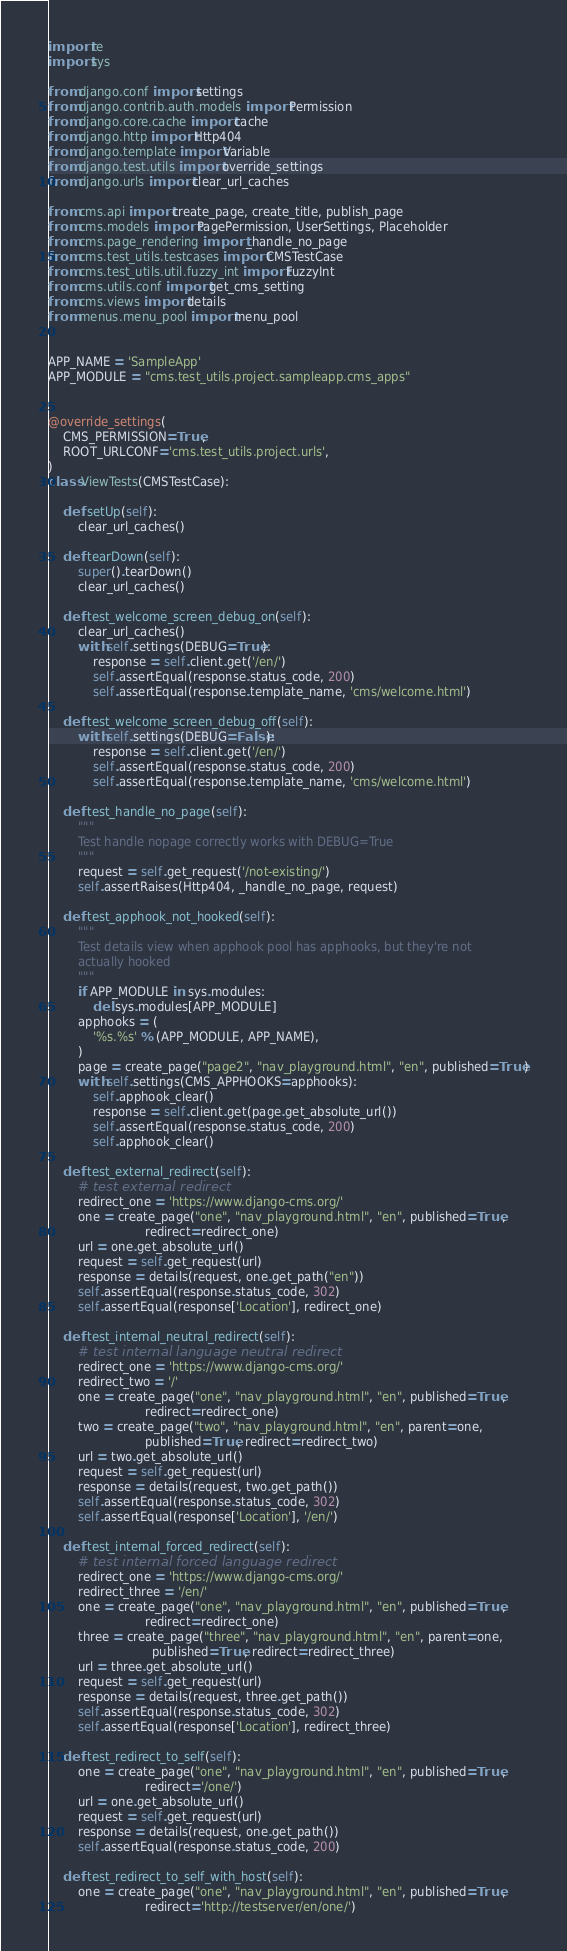Convert code to text. <code><loc_0><loc_0><loc_500><loc_500><_Python_>import re
import sys

from django.conf import settings
from django.contrib.auth.models import Permission
from django.core.cache import cache
from django.http import Http404
from django.template import Variable
from django.test.utils import override_settings
from django.urls import clear_url_caches

from cms.api import create_page, create_title, publish_page
from cms.models import PagePermission, UserSettings, Placeholder
from cms.page_rendering import _handle_no_page
from cms.test_utils.testcases import CMSTestCase
from cms.test_utils.util.fuzzy_int import FuzzyInt
from cms.utils.conf import get_cms_setting
from cms.views import details
from menus.menu_pool import menu_pool


APP_NAME = 'SampleApp'
APP_MODULE = "cms.test_utils.project.sampleapp.cms_apps"


@override_settings(
    CMS_PERMISSION=True,
    ROOT_URLCONF='cms.test_utils.project.urls',
)
class ViewTests(CMSTestCase):

    def setUp(self):
        clear_url_caches()

    def tearDown(self):
        super().tearDown()
        clear_url_caches()

    def test_welcome_screen_debug_on(self):
        clear_url_caches()
        with self.settings(DEBUG=True):
            response = self.client.get('/en/')
            self.assertEqual(response.status_code, 200)
            self.assertEqual(response.template_name, 'cms/welcome.html')

    def test_welcome_screen_debug_off(self):
        with self.settings(DEBUG=False):
            response = self.client.get('/en/')
            self.assertEqual(response.status_code, 200)
            self.assertEqual(response.template_name, 'cms/welcome.html')

    def test_handle_no_page(self):
        """
        Test handle nopage correctly works with DEBUG=True
        """
        request = self.get_request('/not-existing/')
        self.assertRaises(Http404, _handle_no_page, request)

    def test_apphook_not_hooked(self):
        """
        Test details view when apphook pool has apphooks, but they're not
        actually hooked
        """
        if APP_MODULE in sys.modules:
            del sys.modules[APP_MODULE]
        apphooks = (
            '%s.%s' % (APP_MODULE, APP_NAME),
        )
        page = create_page("page2", "nav_playground.html", "en", published=True)
        with self.settings(CMS_APPHOOKS=apphooks):
            self.apphook_clear()
            response = self.client.get(page.get_absolute_url())
            self.assertEqual(response.status_code, 200)
            self.apphook_clear()

    def test_external_redirect(self):
        # test external redirect
        redirect_one = 'https://www.django-cms.org/'
        one = create_page("one", "nav_playground.html", "en", published=True,
                          redirect=redirect_one)
        url = one.get_absolute_url()
        request = self.get_request(url)
        response = details(request, one.get_path("en"))
        self.assertEqual(response.status_code, 302)
        self.assertEqual(response['Location'], redirect_one)

    def test_internal_neutral_redirect(self):
        # test internal language neutral redirect
        redirect_one = 'https://www.django-cms.org/'
        redirect_two = '/'
        one = create_page("one", "nav_playground.html", "en", published=True,
                          redirect=redirect_one)
        two = create_page("two", "nav_playground.html", "en", parent=one,
                          published=True, redirect=redirect_two)
        url = two.get_absolute_url()
        request = self.get_request(url)
        response = details(request, two.get_path())
        self.assertEqual(response.status_code, 302)
        self.assertEqual(response['Location'], '/en/')

    def test_internal_forced_redirect(self):
        # test internal forced language redirect
        redirect_one = 'https://www.django-cms.org/'
        redirect_three = '/en/'
        one = create_page("one", "nav_playground.html", "en", published=True,
                          redirect=redirect_one)
        three = create_page("three", "nav_playground.html", "en", parent=one,
                            published=True, redirect=redirect_three)
        url = three.get_absolute_url()
        request = self.get_request(url)
        response = details(request, three.get_path())
        self.assertEqual(response.status_code, 302)
        self.assertEqual(response['Location'], redirect_three)

    def test_redirect_to_self(self):
        one = create_page("one", "nav_playground.html", "en", published=True,
                          redirect='/one/')
        url = one.get_absolute_url()
        request = self.get_request(url)
        response = details(request, one.get_path())
        self.assertEqual(response.status_code, 200)

    def test_redirect_to_self_with_host(self):
        one = create_page("one", "nav_playground.html", "en", published=True,
                          redirect='http://testserver/en/one/')</code> 